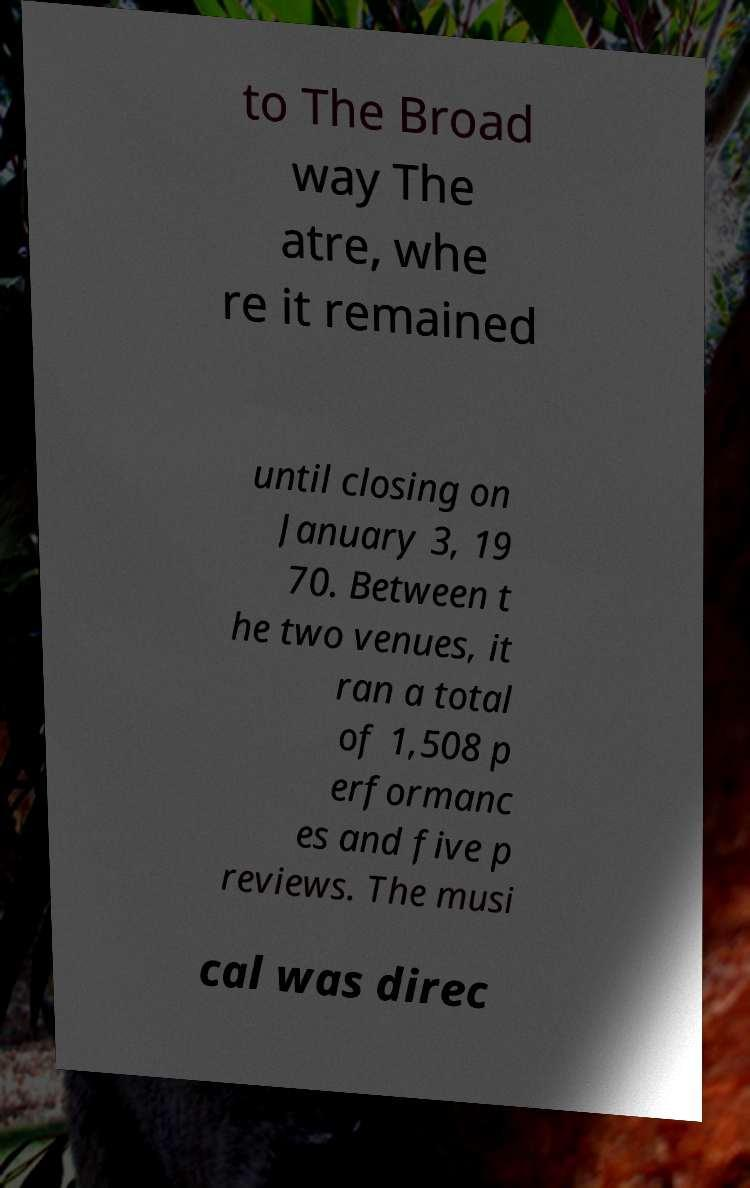I need the written content from this picture converted into text. Can you do that? to The Broad way The atre, whe re it remained until closing on January 3, 19 70. Between t he two venues, it ran a total of 1,508 p erformanc es and five p reviews. The musi cal was direc 